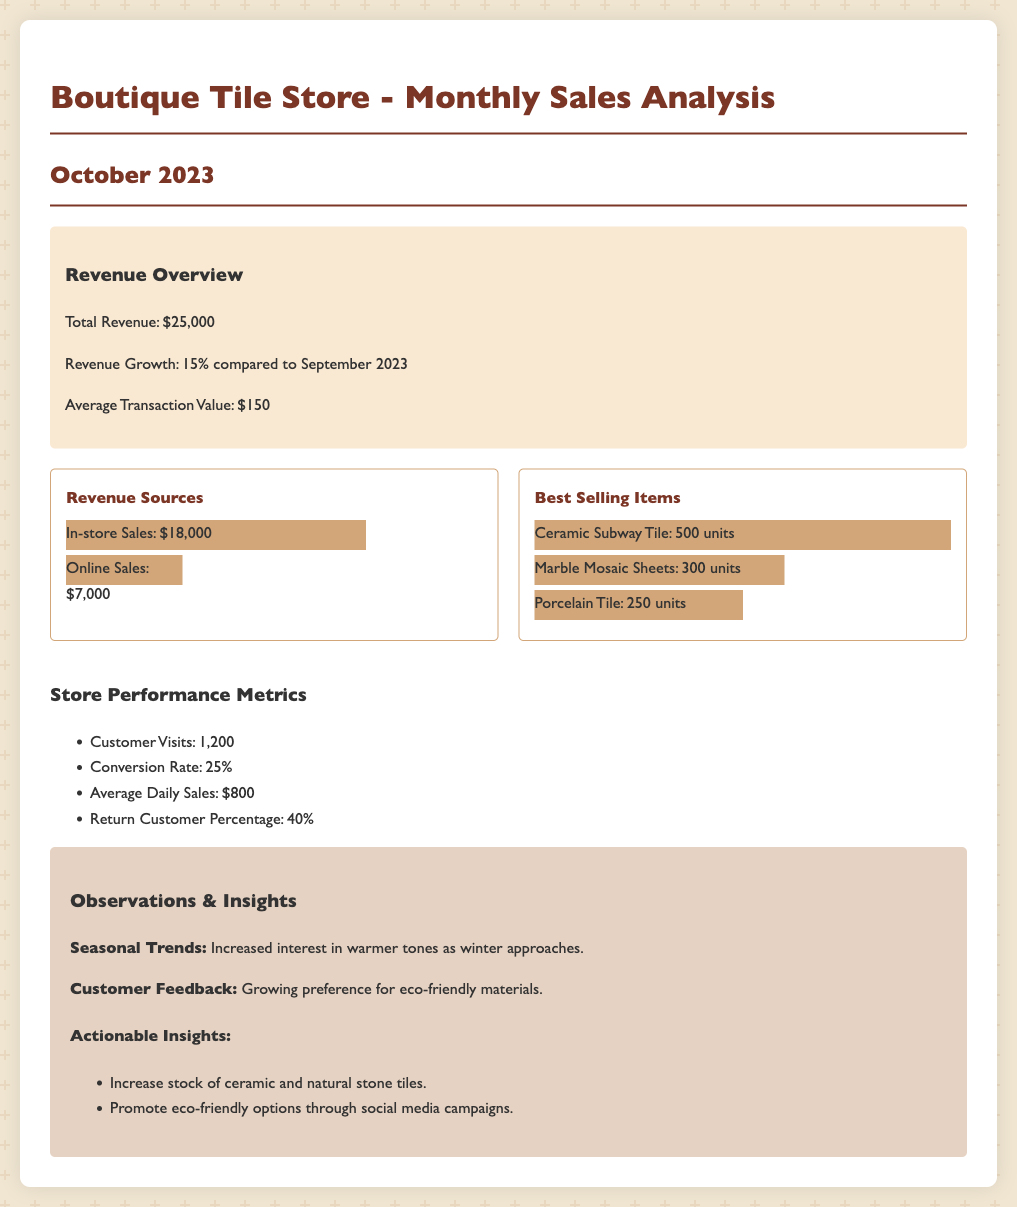What is the total revenue? The total revenue is explicitly stated in the document as $25,000.
Answer: $25,000 What is the revenue growth compared to September 2023? The document mentions that the revenue growth is 15% compared to September 2023.
Answer: 15% What is the average transaction value? The average transaction value is provided as $150 in the revenue overview section.
Answer: $150 How many units of Ceramic Subway Tile were sold? The document indicates that 500 units of Ceramic Subway Tile were sold as the best-selling item.
Answer: 500 units What percentage of customers were return customers? The return customer percentage stated in the document is 40%.
Answer: 40% What were the in-store sales revenue? The in-store sales revenue is specified to be $18,000 in the revenue sources.
Answer: $18,000 What is the conversion rate? The conversion rate mentioned in the store performance metrics is 25%.
Answer: 25% What is the average daily sales figure? The average daily sales is stated as $800 in the store performance metrics.
Answer: $800 What insight is provided regarding customer preferences? The document notes a growing preference for eco-friendly materials based on customer feedback.
Answer: Eco-friendly materials 